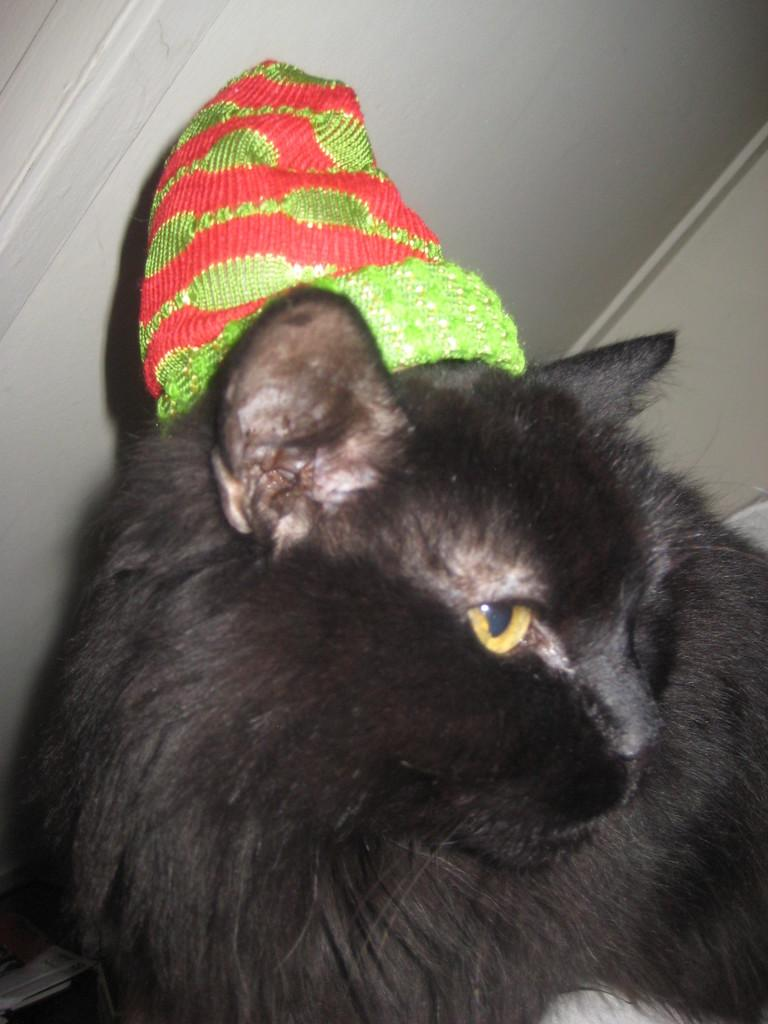What type of animal is in the image? There is a black cat in the image. What is the cat wearing? The cat is wearing a cap. What color is the wall visible at the top of the image? The wall is white. What type of cracker is the cat holding in the image? There is no cracker present in the image; the cat is wearing a cap but not holding anything. 